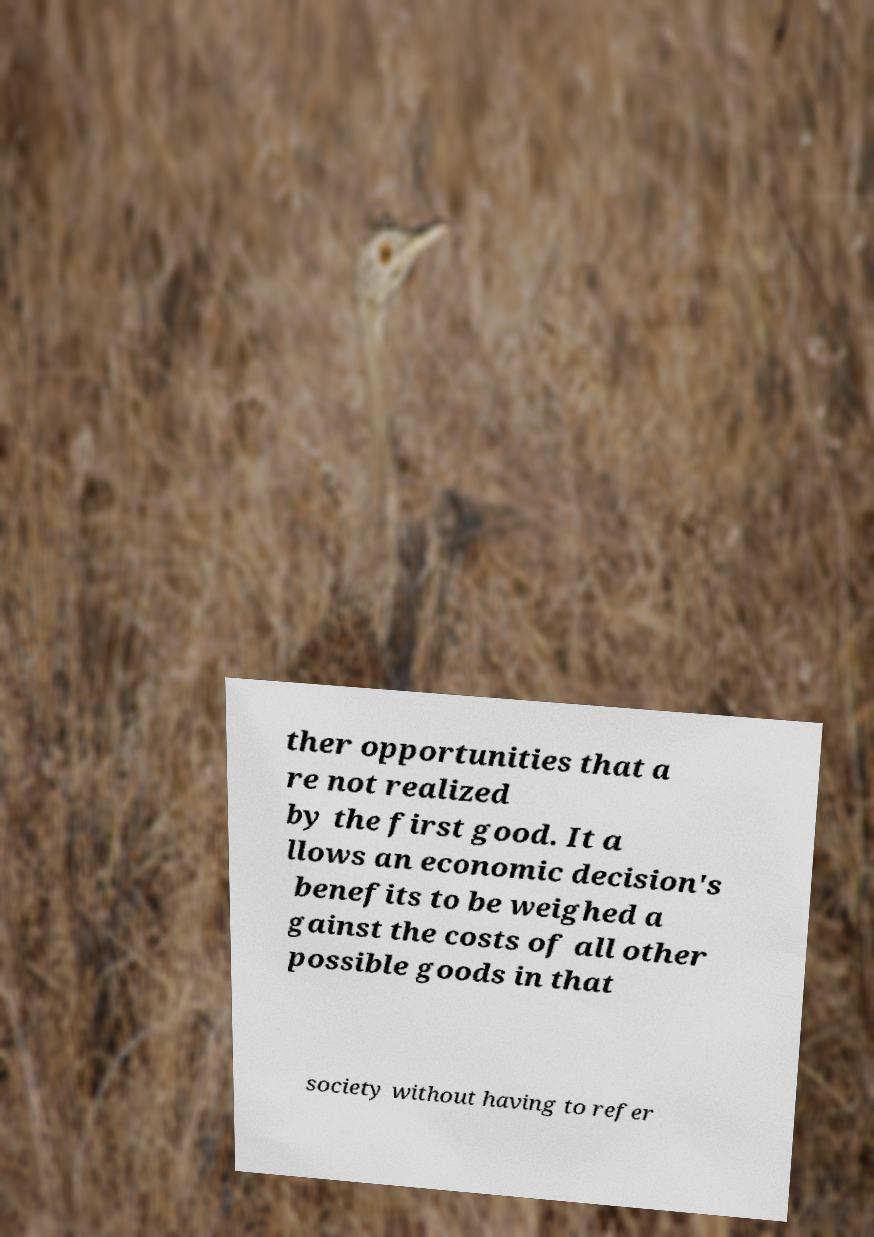Could you extract and type out the text from this image? ther opportunities that a re not realized by the first good. It a llows an economic decision's benefits to be weighed a gainst the costs of all other possible goods in that society without having to refer 